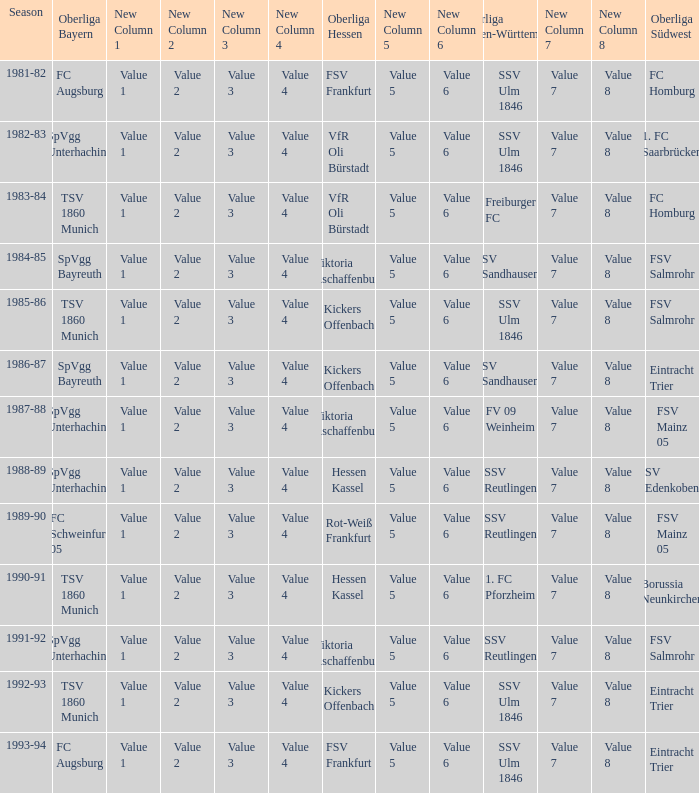Which Oberliga Südwest has an Oberliga Bayern of fc schweinfurt 05? FSV Mainz 05. 